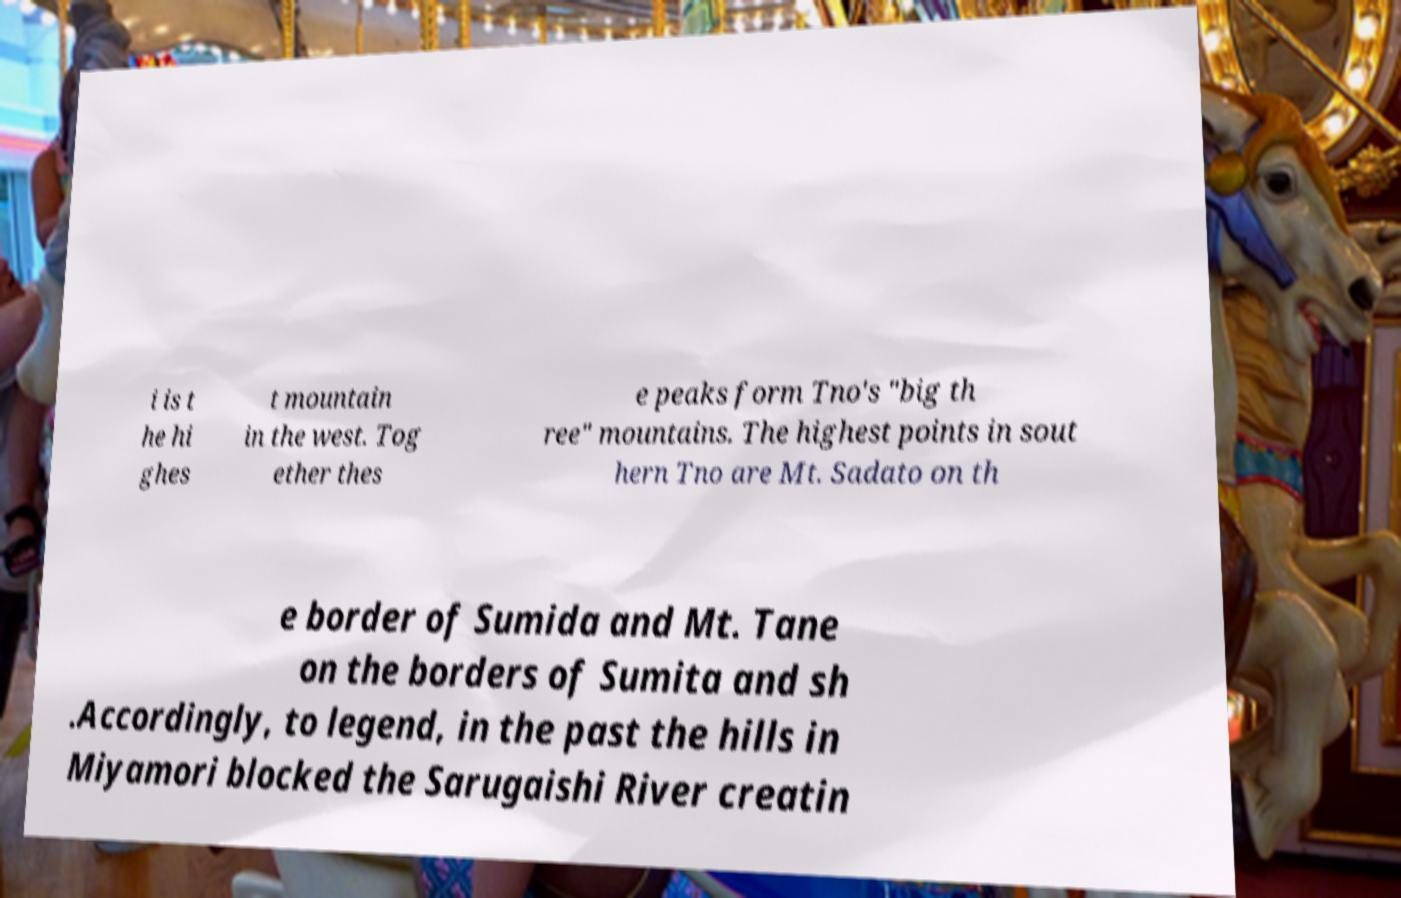Could you extract and type out the text from this image? i is t he hi ghes t mountain in the west. Tog ether thes e peaks form Tno's "big th ree" mountains. The highest points in sout hern Tno are Mt. Sadato on th e border of Sumida and Mt. Tane on the borders of Sumita and sh .Accordingly, to legend, in the past the hills in Miyamori blocked the Sarugaishi River creatin 